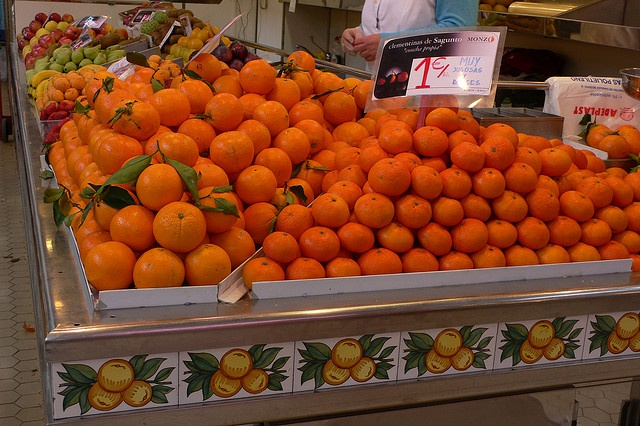Describe the objects in this image and their specific colors. I can see orange in darkblue, maroon, red, and brown tones, people in darkblue, darkgray, gray, and brown tones, orange in darkblue, maroon, brown, and red tones, orange in darkblue, brown, red, and maroon tones, and orange in darkblue, red, maroon, and brown tones in this image. 